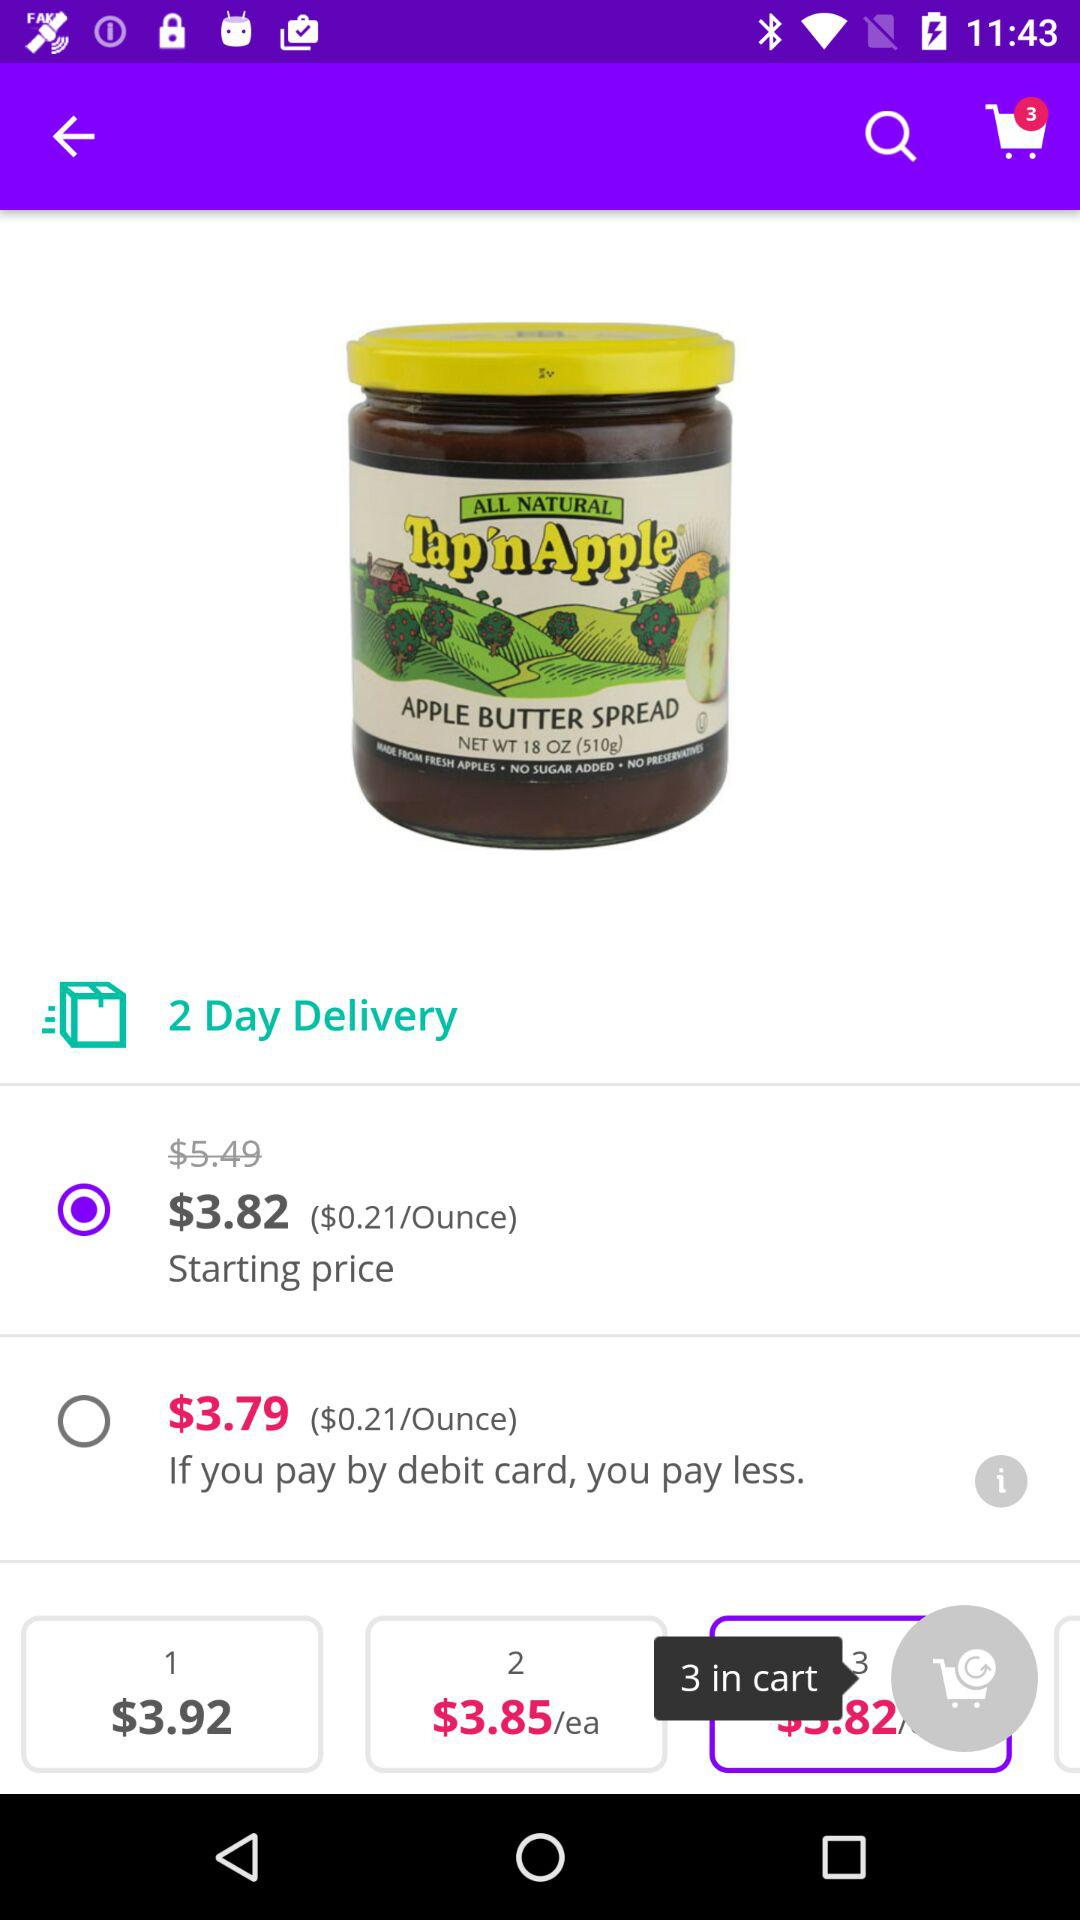In how many days will the item be delivered? The item will be delivered in 2 days. 